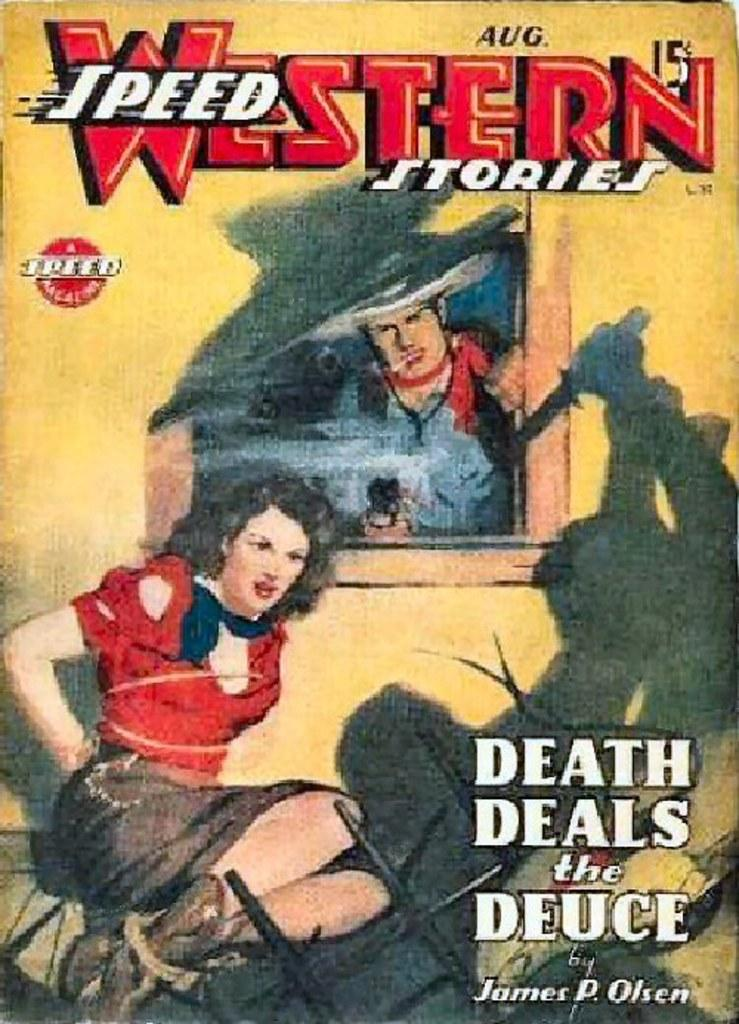What type of visual is the image in question? The image is a poster. What can be seen in the image of the poster? There is an image of two persons on the poster. Are there any textual elements on the poster? Yes, there are words and numbers on the poster. What other design element is present on the poster? There is a symbol on the poster. How does the growth of the two persons on the poster compare? The poster does not depict the growth of the two persons; it only shows an image of them. What role does the father play in the poster? There is no mention of a father or any familial relationship in the poster. 